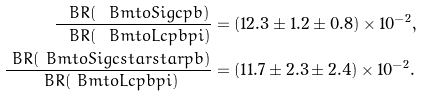<formula> <loc_0><loc_0><loc_500><loc_500>\frac { \ B R ( \ B m t o S i g c p b ) } { \ B R ( \ B m t o L c p b p i ) } & = ( 1 2 . 3 \pm 1 . 2 \pm 0 . 8 ) \times 1 0 ^ { - 2 } , \\ \frac { \ B R ( \ B m t o S i g c s t a r s t a r p b ) } { \ B R ( \ B m t o L c p b p i ) } & = ( 1 1 . 7 \pm 2 . 3 \pm 2 . 4 ) \times 1 0 ^ { - 2 } .</formula> 